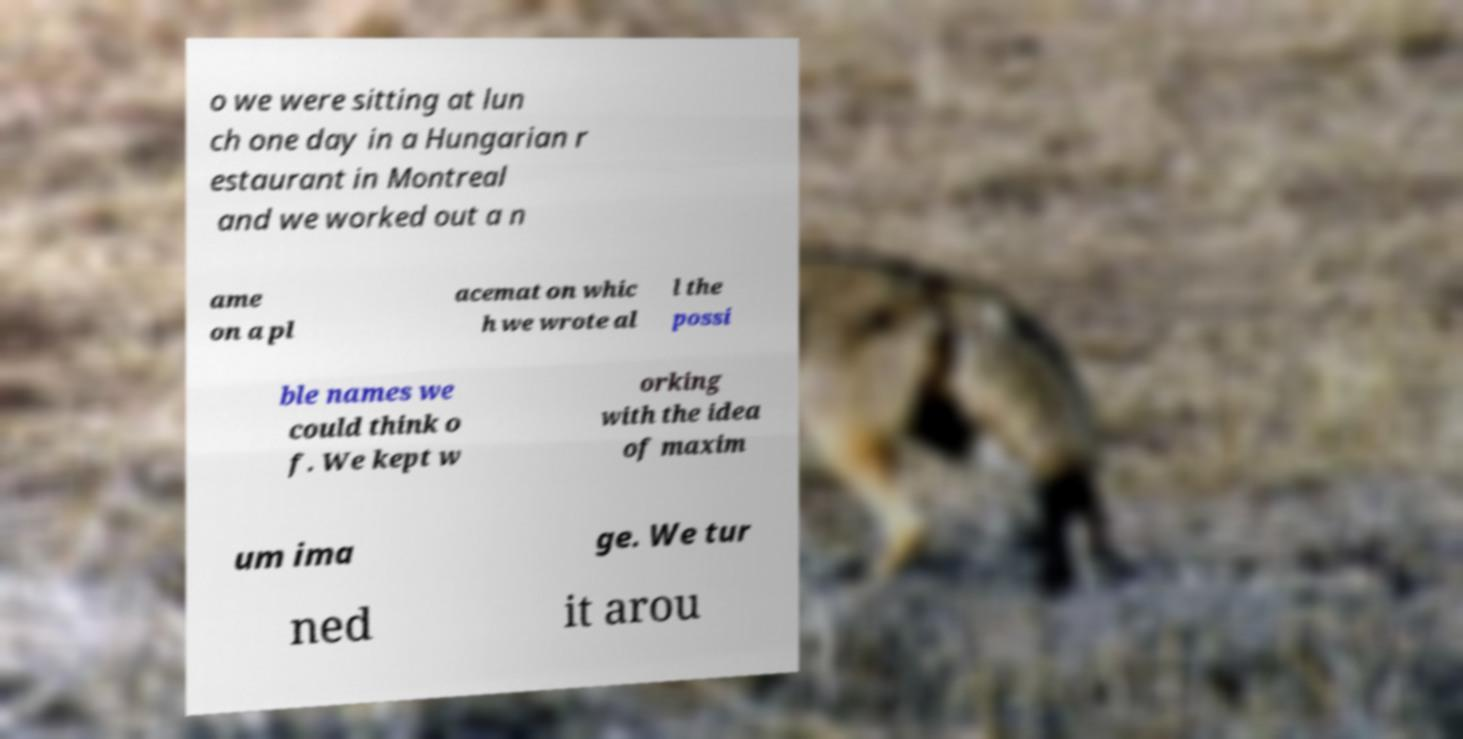Can you accurately transcribe the text from the provided image for me? o we were sitting at lun ch one day in a Hungarian r estaurant in Montreal and we worked out a n ame on a pl acemat on whic h we wrote al l the possi ble names we could think o f. We kept w orking with the idea of maxim um ima ge. We tur ned it arou 